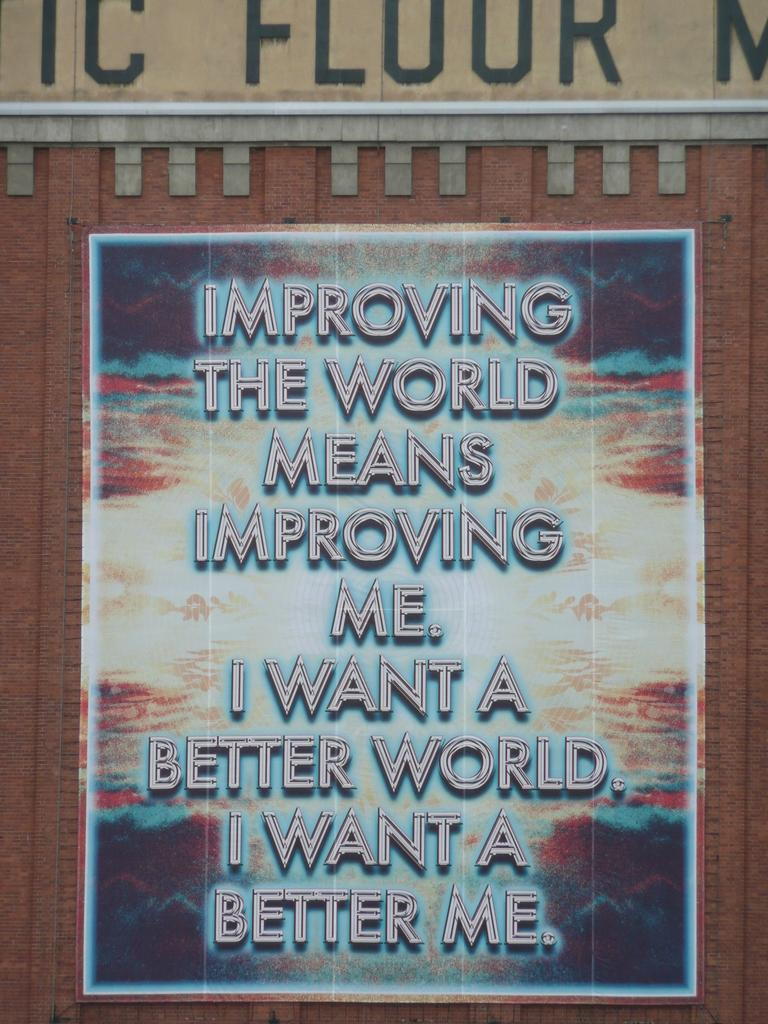<image>
Share a concise interpretation of the image provided. A large sign is on a brick wall with the quote, "Improving the world means improving me." 